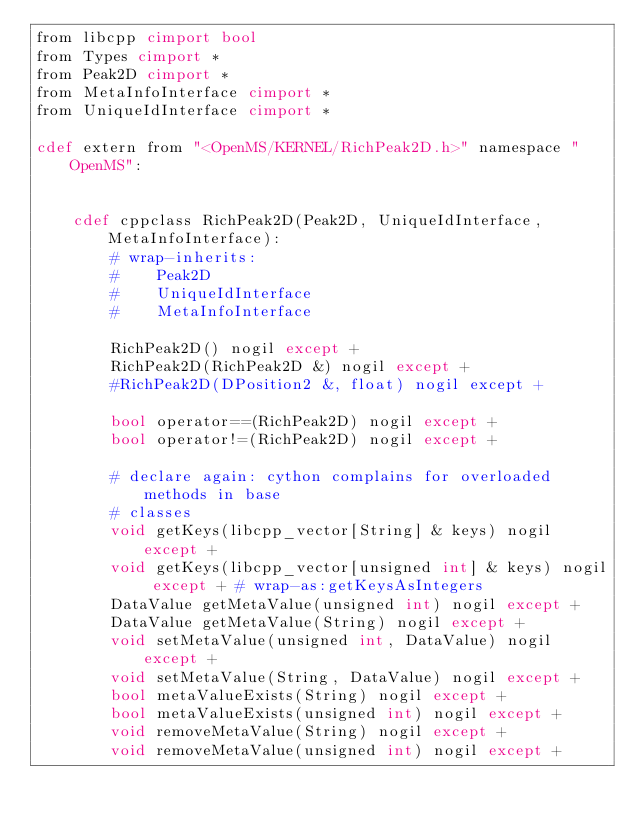Convert code to text. <code><loc_0><loc_0><loc_500><loc_500><_Cython_>from libcpp cimport bool
from Types cimport *
from Peak2D cimport *
from MetaInfoInterface cimport *
from UniqueIdInterface cimport *

cdef extern from "<OpenMS/KERNEL/RichPeak2D.h>" namespace "OpenMS":


    cdef cppclass RichPeak2D(Peak2D, UniqueIdInterface, MetaInfoInterface):
        # wrap-inherits:
        #    Peak2D
        #    UniqueIdInterface
        #    MetaInfoInterface

        RichPeak2D() nogil except +
        RichPeak2D(RichPeak2D &) nogil except +
        #RichPeak2D(DPosition2 &, float) nogil except +

        bool operator==(RichPeak2D) nogil except +
        bool operator!=(RichPeak2D) nogil except +

        # declare again: cython complains for overloaded methods in base
        # classes
        void getKeys(libcpp_vector[String] & keys) nogil except +
        void getKeys(libcpp_vector[unsigned int] & keys) nogil except + # wrap-as:getKeysAsIntegers
        DataValue getMetaValue(unsigned int) nogil except +
        DataValue getMetaValue(String) nogil except +
        void setMetaValue(unsigned int, DataValue) nogil except +
        void setMetaValue(String, DataValue) nogil except +
        bool metaValueExists(String) nogil except +
        bool metaValueExists(unsigned int) nogil except +
        void removeMetaValue(String) nogil except +
        void removeMetaValue(unsigned int) nogil except +
</code> 